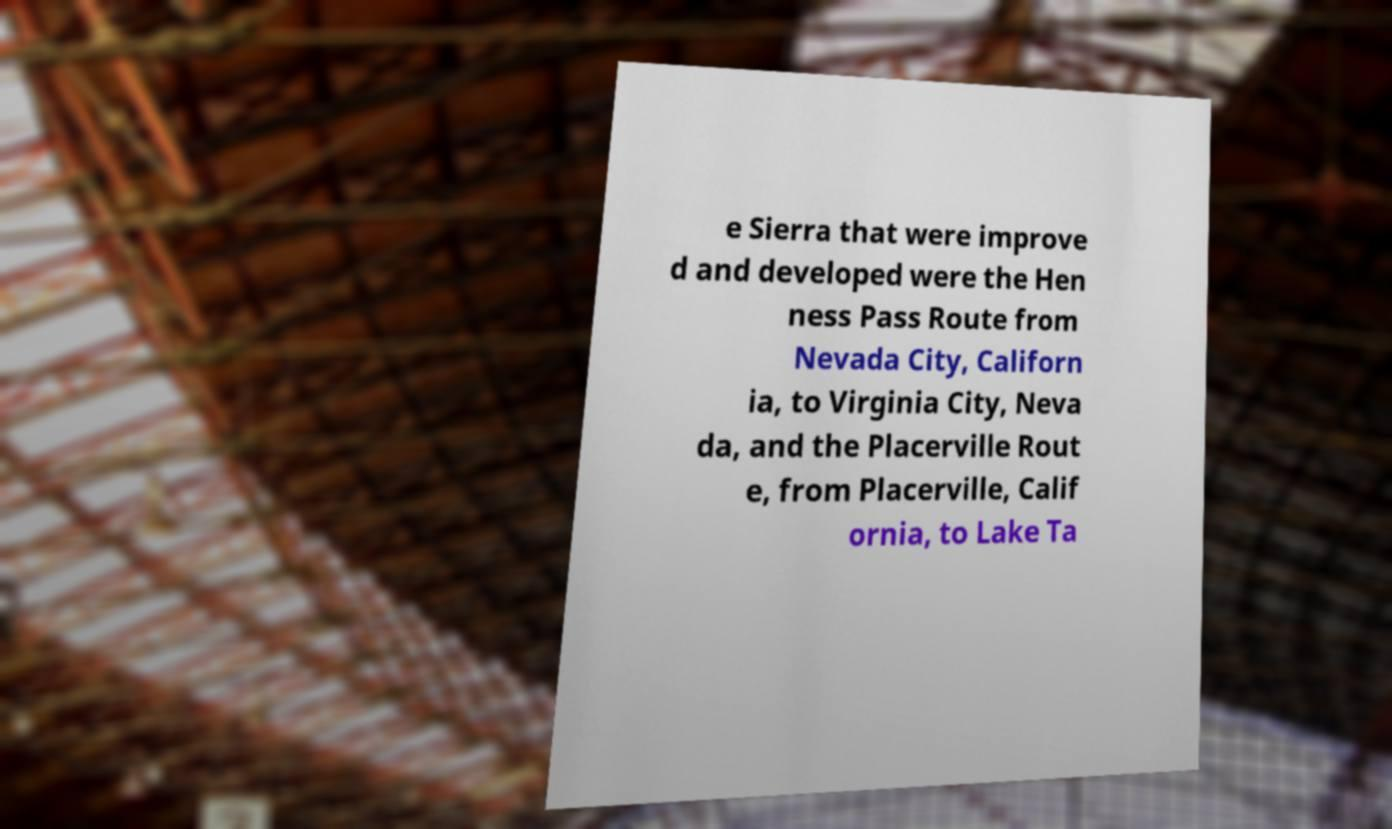I need the written content from this picture converted into text. Can you do that? e Sierra that were improve d and developed were the Hen ness Pass Route from Nevada City, Californ ia, to Virginia City, Neva da, and the Placerville Rout e, from Placerville, Calif ornia, to Lake Ta 